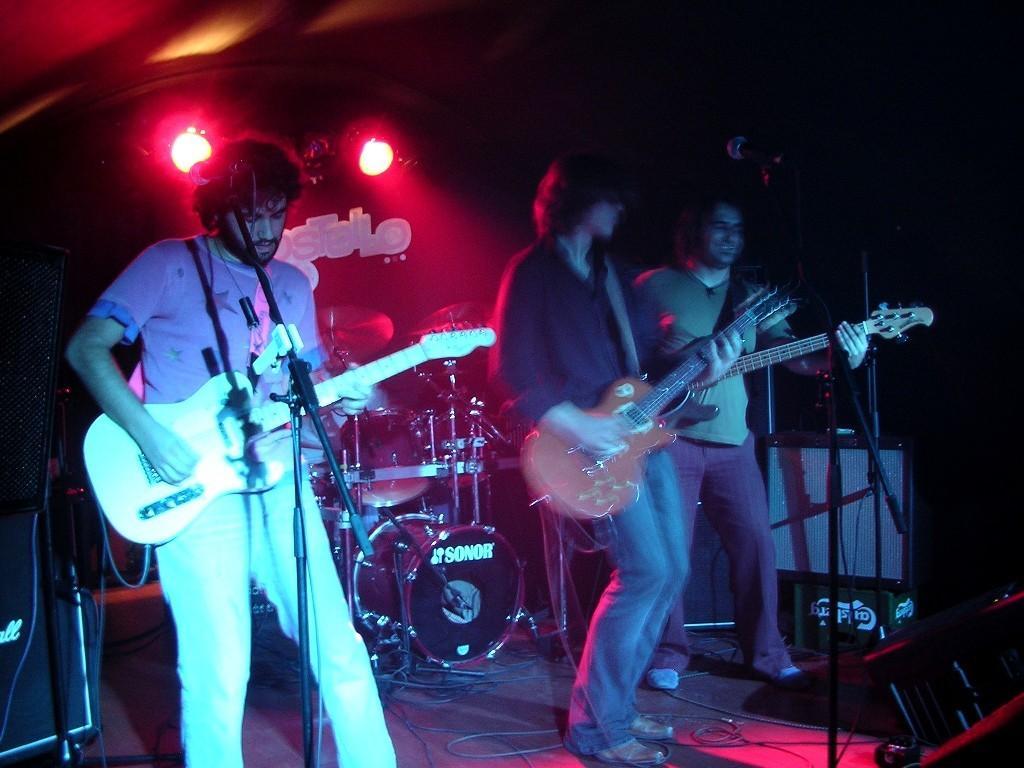Please provide a concise description of this image. In this image we can see three people are standing on the stage and playing the guitar in their hands. There is an electronic drums in the background. 